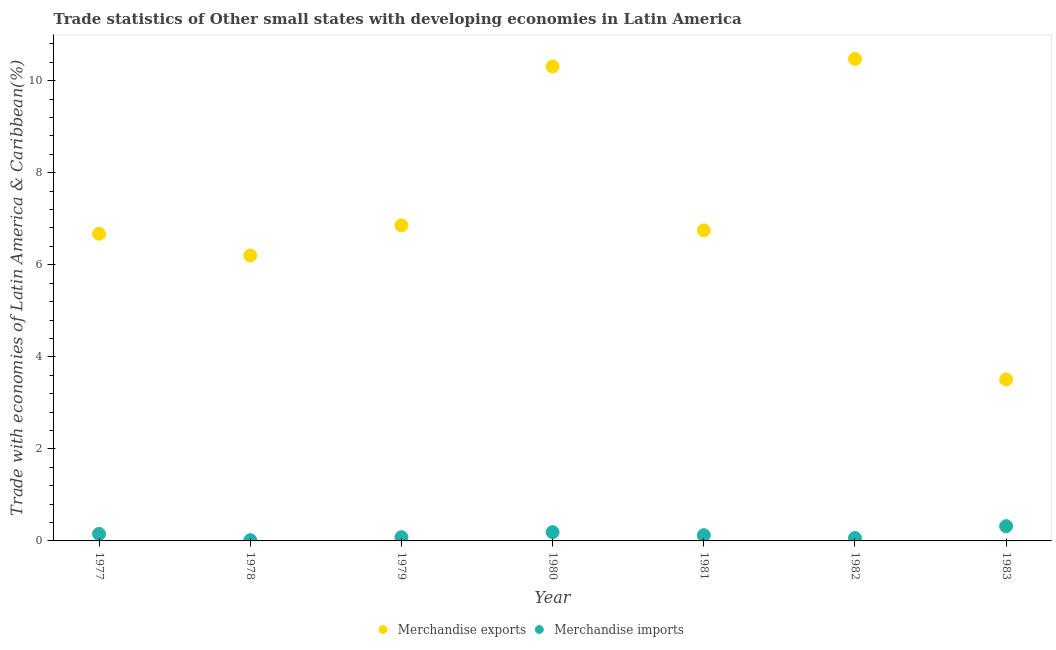How many different coloured dotlines are there?
Offer a very short reply. 2. Is the number of dotlines equal to the number of legend labels?
Ensure brevity in your answer.  Yes. What is the merchandise exports in 1979?
Your answer should be compact. 6.86. Across all years, what is the maximum merchandise imports?
Offer a very short reply. 0.32. Across all years, what is the minimum merchandise imports?
Your response must be concise. 0.02. In which year was the merchandise imports maximum?
Make the answer very short. 1983. In which year was the merchandise imports minimum?
Offer a very short reply. 1978. What is the total merchandise imports in the graph?
Your answer should be very brief. 0.95. What is the difference between the merchandise exports in 1981 and that in 1983?
Your response must be concise. 3.24. What is the difference between the merchandise imports in 1981 and the merchandise exports in 1983?
Your answer should be very brief. -3.38. What is the average merchandise imports per year?
Make the answer very short. 0.14. In the year 1979, what is the difference between the merchandise exports and merchandise imports?
Keep it short and to the point. 6.77. In how many years, is the merchandise imports greater than 2.4 %?
Your answer should be compact. 0. What is the ratio of the merchandise imports in 1979 to that in 1981?
Keep it short and to the point. 0.65. Is the merchandise imports in 1979 less than that in 1981?
Your response must be concise. Yes. What is the difference between the highest and the second highest merchandise imports?
Your response must be concise. 0.13. What is the difference between the highest and the lowest merchandise imports?
Offer a very short reply. 0.3. In how many years, is the merchandise exports greater than the average merchandise exports taken over all years?
Offer a very short reply. 2. Is the merchandise imports strictly greater than the merchandise exports over the years?
Make the answer very short. No. How many years are there in the graph?
Offer a very short reply. 7. What is the difference between two consecutive major ticks on the Y-axis?
Ensure brevity in your answer.  2. Does the graph contain any zero values?
Your answer should be compact. No. How many legend labels are there?
Provide a short and direct response. 2. How are the legend labels stacked?
Keep it short and to the point. Horizontal. What is the title of the graph?
Your answer should be compact. Trade statistics of Other small states with developing economies in Latin America. Does "Short-term debt" appear as one of the legend labels in the graph?
Provide a succinct answer. No. What is the label or title of the Y-axis?
Provide a succinct answer. Trade with economies of Latin America & Caribbean(%). What is the Trade with economies of Latin America & Caribbean(%) of Merchandise exports in 1977?
Your answer should be compact. 6.67. What is the Trade with economies of Latin America & Caribbean(%) in Merchandise imports in 1977?
Your response must be concise. 0.15. What is the Trade with economies of Latin America & Caribbean(%) in Merchandise exports in 1978?
Provide a succinct answer. 6.2. What is the Trade with economies of Latin America & Caribbean(%) in Merchandise imports in 1978?
Keep it short and to the point. 0.02. What is the Trade with economies of Latin America & Caribbean(%) of Merchandise exports in 1979?
Ensure brevity in your answer.  6.86. What is the Trade with economies of Latin America & Caribbean(%) in Merchandise imports in 1979?
Offer a very short reply. 0.08. What is the Trade with economies of Latin America & Caribbean(%) of Merchandise exports in 1980?
Offer a very short reply. 10.31. What is the Trade with economies of Latin America & Caribbean(%) of Merchandise imports in 1980?
Provide a short and direct response. 0.19. What is the Trade with economies of Latin America & Caribbean(%) in Merchandise exports in 1981?
Provide a short and direct response. 6.75. What is the Trade with economies of Latin America & Caribbean(%) in Merchandise imports in 1981?
Your answer should be compact. 0.12. What is the Trade with economies of Latin America & Caribbean(%) of Merchandise exports in 1982?
Provide a succinct answer. 10.47. What is the Trade with economies of Latin America & Caribbean(%) of Merchandise imports in 1982?
Keep it short and to the point. 0.06. What is the Trade with economies of Latin America & Caribbean(%) of Merchandise exports in 1983?
Your answer should be compact. 3.51. What is the Trade with economies of Latin America & Caribbean(%) in Merchandise imports in 1983?
Make the answer very short. 0.32. Across all years, what is the maximum Trade with economies of Latin America & Caribbean(%) of Merchandise exports?
Your answer should be very brief. 10.47. Across all years, what is the maximum Trade with economies of Latin America & Caribbean(%) of Merchandise imports?
Make the answer very short. 0.32. Across all years, what is the minimum Trade with economies of Latin America & Caribbean(%) of Merchandise exports?
Keep it short and to the point. 3.51. Across all years, what is the minimum Trade with economies of Latin America & Caribbean(%) of Merchandise imports?
Ensure brevity in your answer.  0.02. What is the total Trade with economies of Latin America & Caribbean(%) of Merchandise exports in the graph?
Keep it short and to the point. 50.77. What is the total Trade with economies of Latin America & Caribbean(%) in Merchandise imports in the graph?
Offer a very short reply. 0.95. What is the difference between the Trade with economies of Latin America & Caribbean(%) of Merchandise exports in 1977 and that in 1978?
Your answer should be very brief. 0.47. What is the difference between the Trade with economies of Latin America & Caribbean(%) in Merchandise imports in 1977 and that in 1978?
Provide a short and direct response. 0.14. What is the difference between the Trade with economies of Latin America & Caribbean(%) in Merchandise exports in 1977 and that in 1979?
Provide a succinct answer. -0.18. What is the difference between the Trade with economies of Latin America & Caribbean(%) in Merchandise imports in 1977 and that in 1979?
Offer a terse response. 0.07. What is the difference between the Trade with economies of Latin America & Caribbean(%) of Merchandise exports in 1977 and that in 1980?
Your response must be concise. -3.63. What is the difference between the Trade with economies of Latin America & Caribbean(%) of Merchandise imports in 1977 and that in 1980?
Give a very brief answer. -0.04. What is the difference between the Trade with economies of Latin America & Caribbean(%) of Merchandise exports in 1977 and that in 1981?
Your answer should be very brief. -0.08. What is the difference between the Trade with economies of Latin America & Caribbean(%) of Merchandise imports in 1977 and that in 1981?
Your answer should be compact. 0.03. What is the difference between the Trade with economies of Latin America & Caribbean(%) of Merchandise exports in 1977 and that in 1982?
Your response must be concise. -3.8. What is the difference between the Trade with economies of Latin America & Caribbean(%) of Merchandise imports in 1977 and that in 1982?
Your response must be concise. 0.09. What is the difference between the Trade with economies of Latin America & Caribbean(%) of Merchandise exports in 1977 and that in 1983?
Your response must be concise. 3.17. What is the difference between the Trade with economies of Latin America & Caribbean(%) of Merchandise imports in 1977 and that in 1983?
Provide a succinct answer. -0.17. What is the difference between the Trade with economies of Latin America & Caribbean(%) of Merchandise exports in 1978 and that in 1979?
Offer a terse response. -0.65. What is the difference between the Trade with economies of Latin America & Caribbean(%) in Merchandise imports in 1978 and that in 1979?
Your answer should be very brief. -0.07. What is the difference between the Trade with economies of Latin America & Caribbean(%) in Merchandise exports in 1978 and that in 1980?
Offer a terse response. -4.11. What is the difference between the Trade with economies of Latin America & Caribbean(%) in Merchandise imports in 1978 and that in 1980?
Make the answer very short. -0.17. What is the difference between the Trade with economies of Latin America & Caribbean(%) in Merchandise exports in 1978 and that in 1981?
Give a very brief answer. -0.55. What is the difference between the Trade with economies of Latin America & Caribbean(%) in Merchandise imports in 1978 and that in 1981?
Offer a terse response. -0.11. What is the difference between the Trade with economies of Latin America & Caribbean(%) of Merchandise exports in 1978 and that in 1982?
Your response must be concise. -4.27. What is the difference between the Trade with economies of Latin America & Caribbean(%) of Merchandise imports in 1978 and that in 1982?
Your answer should be compact. -0.05. What is the difference between the Trade with economies of Latin America & Caribbean(%) of Merchandise exports in 1978 and that in 1983?
Give a very brief answer. 2.69. What is the difference between the Trade with economies of Latin America & Caribbean(%) of Merchandise imports in 1978 and that in 1983?
Offer a very short reply. -0.3. What is the difference between the Trade with economies of Latin America & Caribbean(%) of Merchandise exports in 1979 and that in 1980?
Offer a terse response. -3.45. What is the difference between the Trade with economies of Latin America & Caribbean(%) of Merchandise imports in 1979 and that in 1980?
Your response must be concise. -0.11. What is the difference between the Trade with economies of Latin America & Caribbean(%) of Merchandise exports in 1979 and that in 1981?
Provide a short and direct response. 0.11. What is the difference between the Trade with economies of Latin America & Caribbean(%) in Merchandise imports in 1979 and that in 1981?
Keep it short and to the point. -0.04. What is the difference between the Trade with economies of Latin America & Caribbean(%) in Merchandise exports in 1979 and that in 1982?
Your answer should be very brief. -3.62. What is the difference between the Trade with economies of Latin America & Caribbean(%) in Merchandise imports in 1979 and that in 1982?
Your response must be concise. 0.02. What is the difference between the Trade with economies of Latin America & Caribbean(%) of Merchandise exports in 1979 and that in 1983?
Provide a succinct answer. 3.35. What is the difference between the Trade with economies of Latin America & Caribbean(%) of Merchandise imports in 1979 and that in 1983?
Offer a very short reply. -0.24. What is the difference between the Trade with economies of Latin America & Caribbean(%) of Merchandise exports in 1980 and that in 1981?
Your response must be concise. 3.56. What is the difference between the Trade with economies of Latin America & Caribbean(%) in Merchandise imports in 1980 and that in 1981?
Ensure brevity in your answer.  0.07. What is the difference between the Trade with economies of Latin America & Caribbean(%) in Merchandise exports in 1980 and that in 1982?
Your answer should be compact. -0.16. What is the difference between the Trade with economies of Latin America & Caribbean(%) of Merchandise imports in 1980 and that in 1982?
Offer a very short reply. 0.13. What is the difference between the Trade with economies of Latin America & Caribbean(%) of Merchandise exports in 1980 and that in 1983?
Your answer should be compact. 6.8. What is the difference between the Trade with economies of Latin America & Caribbean(%) in Merchandise imports in 1980 and that in 1983?
Offer a terse response. -0.13. What is the difference between the Trade with economies of Latin America & Caribbean(%) of Merchandise exports in 1981 and that in 1982?
Give a very brief answer. -3.72. What is the difference between the Trade with economies of Latin America & Caribbean(%) of Merchandise imports in 1981 and that in 1982?
Ensure brevity in your answer.  0.06. What is the difference between the Trade with economies of Latin America & Caribbean(%) in Merchandise exports in 1981 and that in 1983?
Offer a terse response. 3.24. What is the difference between the Trade with economies of Latin America & Caribbean(%) in Merchandise imports in 1981 and that in 1983?
Provide a short and direct response. -0.2. What is the difference between the Trade with economies of Latin America & Caribbean(%) in Merchandise exports in 1982 and that in 1983?
Give a very brief answer. 6.96. What is the difference between the Trade with economies of Latin America & Caribbean(%) in Merchandise imports in 1982 and that in 1983?
Ensure brevity in your answer.  -0.26. What is the difference between the Trade with economies of Latin America & Caribbean(%) of Merchandise exports in 1977 and the Trade with economies of Latin America & Caribbean(%) of Merchandise imports in 1978?
Offer a terse response. 6.66. What is the difference between the Trade with economies of Latin America & Caribbean(%) of Merchandise exports in 1977 and the Trade with economies of Latin America & Caribbean(%) of Merchandise imports in 1979?
Offer a very short reply. 6.59. What is the difference between the Trade with economies of Latin America & Caribbean(%) in Merchandise exports in 1977 and the Trade with economies of Latin America & Caribbean(%) in Merchandise imports in 1980?
Offer a very short reply. 6.48. What is the difference between the Trade with economies of Latin America & Caribbean(%) of Merchandise exports in 1977 and the Trade with economies of Latin America & Caribbean(%) of Merchandise imports in 1981?
Provide a succinct answer. 6.55. What is the difference between the Trade with economies of Latin America & Caribbean(%) in Merchandise exports in 1977 and the Trade with economies of Latin America & Caribbean(%) in Merchandise imports in 1982?
Keep it short and to the point. 6.61. What is the difference between the Trade with economies of Latin America & Caribbean(%) of Merchandise exports in 1977 and the Trade with economies of Latin America & Caribbean(%) of Merchandise imports in 1983?
Keep it short and to the point. 6.35. What is the difference between the Trade with economies of Latin America & Caribbean(%) in Merchandise exports in 1978 and the Trade with economies of Latin America & Caribbean(%) in Merchandise imports in 1979?
Provide a succinct answer. 6.12. What is the difference between the Trade with economies of Latin America & Caribbean(%) of Merchandise exports in 1978 and the Trade with economies of Latin America & Caribbean(%) of Merchandise imports in 1980?
Your answer should be very brief. 6.01. What is the difference between the Trade with economies of Latin America & Caribbean(%) of Merchandise exports in 1978 and the Trade with economies of Latin America & Caribbean(%) of Merchandise imports in 1981?
Make the answer very short. 6.08. What is the difference between the Trade with economies of Latin America & Caribbean(%) in Merchandise exports in 1978 and the Trade with economies of Latin America & Caribbean(%) in Merchandise imports in 1982?
Your answer should be very brief. 6.14. What is the difference between the Trade with economies of Latin America & Caribbean(%) of Merchandise exports in 1978 and the Trade with economies of Latin America & Caribbean(%) of Merchandise imports in 1983?
Provide a succinct answer. 5.88. What is the difference between the Trade with economies of Latin America & Caribbean(%) of Merchandise exports in 1979 and the Trade with economies of Latin America & Caribbean(%) of Merchandise imports in 1980?
Offer a terse response. 6.67. What is the difference between the Trade with economies of Latin America & Caribbean(%) in Merchandise exports in 1979 and the Trade with economies of Latin America & Caribbean(%) in Merchandise imports in 1981?
Make the answer very short. 6.73. What is the difference between the Trade with economies of Latin America & Caribbean(%) of Merchandise exports in 1979 and the Trade with economies of Latin America & Caribbean(%) of Merchandise imports in 1982?
Your answer should be compact. 6.79. What is the difference between the Trade with economies of Latin America & Caribbean(%) in Merchandise exports in 1979 and the Trade with economies of Latin America & Caribbean(%) in Merchandise imports in 1983?
Provide a short and direct response. 6.54. What is the difference between the Trade with economies of Latin America & Caribbean(%) in Merchandise exports in 1980 and the Trade with economies of Latin America & Caribbean(%) in Merchandise imports in 1981?
Offer a very short reply. 10.18. What is the difference between the Trade with economies of Latin America & Caribbean(%) of Merchandise exports in 1980 and the Trade with economies of Latin America & Caribbean(%) of Merchandise imports in 1982?
Your answer should be very brief. 10.25. What is the difference between the Trade with economies of Latin America & Caribbean(%) of Merchandise exports in 1980 and the Trade with economies of Latin America & Caribbean(%) of Merchandise imports in 1983?
Offer a very short reply. 9.99. What is the difference between the Trade with economies of Latin America & Caribbean(%) in Merchandise exports in 1981 and the Trade with economies of Latin America & Caribbean(%) in Merchandise imports in 1982?
Provide a succinct answer. 6.69. What is the difference between the Trade with economies of Latin America & Caribbean(%) of Merchandise exports in 1981 and the Trade with economies of Latin America & Caribbean(%) of Merchandise imports in 1983?
Your answer should be compact. 6.43. What is the difference between the Trade with economies of Latin America & Caribbean(%) of Merchandise exports in 1982 and the Trade with economies of Latin America & Caribbean(%) of Merchandise imports in 1983?
Provide a short and direct response. 10.15. What is the average Trade with economies of Latin America & Caribbean(%) in Merchandise exports per year?
Ensure brevity in your answer.  7.25. What is the average Trade with economies of Latin America & Caribbean(%) of Merchandise imports per year?
Your answer should be very brief. 0.14. In the year 1977, what is the difference between the Trade with economies of Latin America & Caribbean(%) of Merchandise exports and Trade with economies of Latin America & Caribbean(%) of Merchandise imports?
Ensure brevity in your answer.  6.52. In the year 1978, what is the difference between the Trade with economies of Latin America & Caribbean(%) of Merchandise exports and Trade with economies of Latin America & Caribbean(%) of Merchandise imports?
Keep it short and to the point. 6.19. In the year 1979, what is the difference between the Trade with economies of Latin America & Caribbean(%) in Merchandise exports and Trade with economies of Latin America & Caribbean(%) in Merchandise imports?
Keep it short and to the point. 6.77. In the year 1980, what is the difference between the Trade with economies of Latin America & Caribbean(%) in Merchandise exports and Trade with economies of Latin America & Caribbean(%) in Merchandise imports?
Offer a very short reply. 10.12. In the year 1981, what is the difference between the Trade with economies of Latin America & Caribbean(%) of Merchandise exports and Trade with economies of Latin America & Caribbean(%) of Merchandise imports?
Your answer should be compact. 6.62. In the year 1982, what is the difference between the Trade with economies of Latin America & Caribbean(%) of Merchandise exports and Trade with economies of Latin America & Caribbean(%) of Merchandise imports?
Give a very brief answer. 10.41. In the year 1983, what is the difference between the Trade with economies of Latin America & Caribbean(%) of Merchandise exports and Trade with economies of Latin America & Caribbean(%) of Merchandise imports?
Your response must be concise. 3.19. What is the ratio of the Trade with economies of Latin America & Caribbean(%) in Merchandise exports in 1977 to that in 1978?
Make the answer very short. 1.08. What is the ratio of the Trade with economies of Latin America & Caribbean(%) of Merchandise imports in 1977 to that in 1978?
Your answer should be compact. 9.55. What is the ratio of the Trade with economies of Latin America & Caribbean(%) in Merchandise exports in 1977 to that in 1979?
Provide a succinct answer. 0.97. What is the ratio of the Trade with economies of Latin America & Caribbean(%) of Merchandise imports in 1977 to that in 1979?
Give a very brief answer. 1.87. What is the ratio of the Trade with economies of Latin America & Caribbean(%) of Merchandise exports in 1977 to that in 1980?
Offer a very short reply. 0.65. What is the ratio of the Trade with economies of Latin America & Caribbean(%) of Merchandise imports in 1977 to that in 1980?
Your answer should be compact. 0.8. What is the ratio of the Trade with economies of Latin America & Caribbean(%) of Merchandise imports in 1977 to that in 1981?
Your answer should be very brief. 1.22. What is the ratio of the Trade with economies of Latin America & Caribbean(%) in Merchandise exports in 1977 to that in 1982?
Make the answer very short. 0.64. What is the ratio of the Trade with economies of Latin America & Caribbean(%) in Merchandise imports in 1977 to that in 1982?
Ensure brevity in your answer.  2.42. What is the ratio of the Trade with economies of Latin America & Caribbean(%) of Merchandise exports in 1977 to that in 1983?
Your answer should be compact. 1.9. What is the ratio of the Trade with economies of Latin America & Caribbean(%) in Merchandise imports in 1977 to that in 1983?
Offer a very short reply. 0.47. What is the ratio of the Trade with economies of Latin America & Caribbean(%) in Merchandise exports in 1978 to that in 1979?
Provide a succinct answer. 0.9. What is the ratio of the Trade with economies of Latin America & Caribbean(%) of Merchandise imports in 1978 to that in 1979?
Provide a succinct answer. 0.2. What is the ratio of the Trade with economies of Latin America & Caribbean(%) of Merchandise exports in 1978 to that in 1980?
Your response must be concise. 0.6. What is the ratio of the Trade with economies of Latin America & Caribbean(%) in Merchandise imports in 1978 to that in 1980?
Offer a terse response. 0.08. What is the ratio of the Trade with economies of Latin America & Caribbean(%) in Merchandise exports in 1978 to that in 1981?
Ensure brevity in your answer.  0.92. What is the ratio of the Trade with economies of Latin America & Caribbean(%) of Merchandise imports in 1978 to that in 1981?
Make the answer very short. 0.13. What is the ratio of the Trade with economies of Latin America & Caribbean(%) of Merchandise exports in 1978 to that in 1982?
Offer a very short reply. 0.59. What is the ratio of the Trade with economies of Latin America & Caribbean(%) of Merchandise imports in 1978 to that in 1982?
Give a very brief answer. 0.25. What is the ratio of the Trade with economies of Latin America & Caribbean(%) in Merchandise exports in 1978 to that in 1983?
Keep it short and to the point. 1.77. What is the ratio of the Trade with economies of Latin America & Caribbean(%) in Merchandise imports in 1978 to that in 1983?
Make the answer very short. 0.05. What is the ratio of the Trade with economies of Latin America & Caribbean(%) of Merchandise exports in 1979 to that in 1980?
Provide a short and direct response. 0.67. What is the ratio of the Trade with economies of Latin America & Caribbean(%) of Merchandise imports in 1979 to that in 1980?
Ensure brevity in your answer.  0.43. What is the ratio of the Trade with economies of Latin America & Caribbean(%) of Merchandise exports in 1979 to that in 1981?
Your answer should be very brief. 1.02. What is the ratio of the Trade with economies of Latin America & Caribbean(%) of Merchandise imports in 1979 to that in 1981?
Make the answer very short. 0.65. What is the ratio of the Trade with economies of Latin America & Caribbean(%) in Merchandise exports in 1979 to that in 1982?
Make the answer very short. 0.65. What is the ratio of the Trade with economies of Latin America & Caribbean(%) in Merchandise imports in 1979 to that in 1982?
Give a very brief answer. 1.3. What is the ratio of the Trade with economies of Latin America & Caribbean(%) in Merchandise exports in 1979 to that in 1983?
Your answer should be compact. 1.95. What is the ratio of the Trade with economies of Latin America & Caribbean(%) in Merchandise imports in 1979 to that in 1983?
Your response must be concise. 0.25. What is the ratio of the Trade with economies of Latin America & Caribbean(%) of Merchandise exports in 1980 to that in 1981?
Offer a very short reply. 1.53. What is the ratio of the Trade with economies of Latin America & Caribbean(%) of Merchandise imports in 1980 to that in 1981?
Your answer should be very brief. 1.53. What is the ratio of the Trade with economies of Latin America & Caribbean(%) in Merchandise exports in 1980 to that in 1982?
Offer a terse response. 0.98. What is the ratio of the Trade with economies of Latin America & Caribbean(%) of Merchandise imports in 1980 to that in 1982?
Offer a terse response. 3.04. What is the ratio of the Trade with economies of Latin America & Caribbean(%) of Merchandise exports in 1980 to that in 1983?
Keep it short and to the point. 2.94. What is the ratio of the Trade with economies of Latin America & Caribbean(%) of Merchandise imports in 1980 to that in 1983?
Your response must be concise. 0.6. What is the ratio of the Trade with economies of Latin America & Caribbean(%) in Merchandise exports in 1981 to that in 1982?
Provide a succinct answer. 0.64. What is the ratio of the Trade with economies of Latin America & Caribbean(%) in Merchandise imports in 1981 to that in 1982?
Provide a succinct answer. 1.98. What is the ratio of the Trade with economies of Latin America & Caribbean(%) in Merchandise exports in 1981 to that in 1983?
Offer a very short reply. 1.92. What is the ratio of the Trade with economies of Latin America & Caribbean(%) of Merchandise imports in 1981 to that in 1983?
Give a very brief answer. 0.39. What is the ratio of the Trade with economies of Latin America & Caribbean(%) in Merchandise exports in 1982 to that in 1983?
Make the answer very short. 2.98. What is the ratio of the Trade with economies of Latin America & Caribbean(%) of Merchandise imports in 1982 to that in 1983?
Your answer should be compact. 0.2. What is the difference between the highest and the second highest Trade with economies of Latin America & Caribbean(%) of Merchandise exports?
Make the answer very short. 0.16. What is the difference between the highest and the second highest Trade with economies of Latin America & Caribbean(%) of Merchandise imports?
Make the answer very short. 0.13. What is the difference between the highest and the lowest Trade with economies of Latin America & Caribbean(%) of Merchandise exports?
Provide a succinct answer. 6.96. What is the difference between the highest and the lowest Trade with economies of Latin America & Caribbean(%) of Merchandise imports?
Offer a terse response. 0.3. 